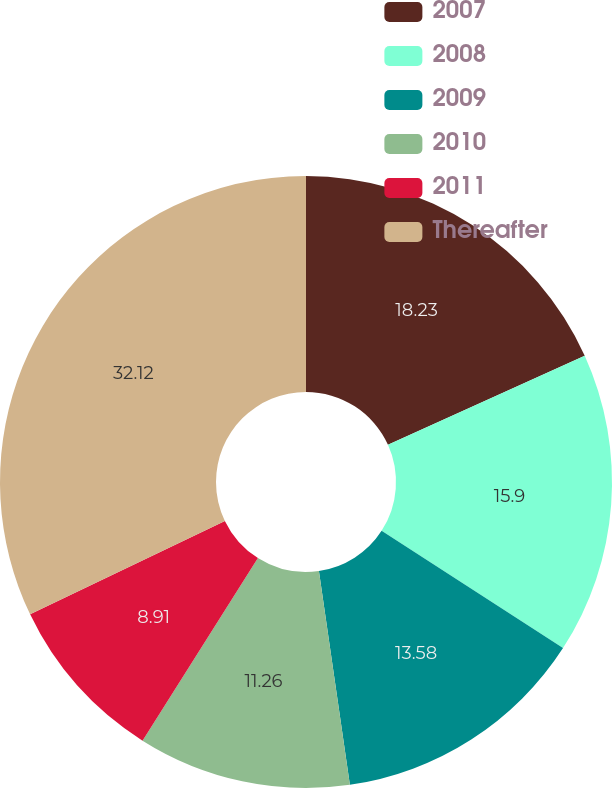Convert chart to OTSL. <chart><loc_0><loc_0><loc_500><loc_500><pie_chart><fcel>2007<fcel>2008<fcel>2009<fcel>2010<fcel>2011<fcel>Thereafter<nl><fcel>18.23%<fcel>15.9%<fcel>13.58%<fcel>11.26%<fcel>8.91%<fcel>32.12%<nl></chart> 